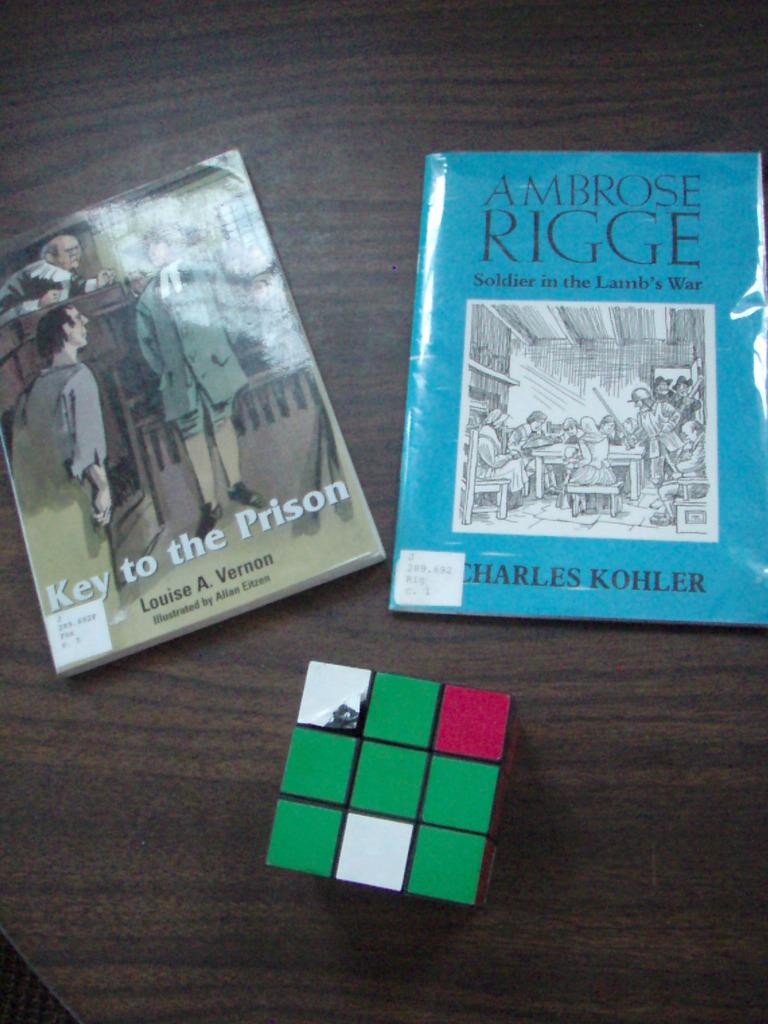<image>
Create a compact narrative representing the image presented. The blue library book written by Charles Kohler is laying above a rubix cube on the table. 